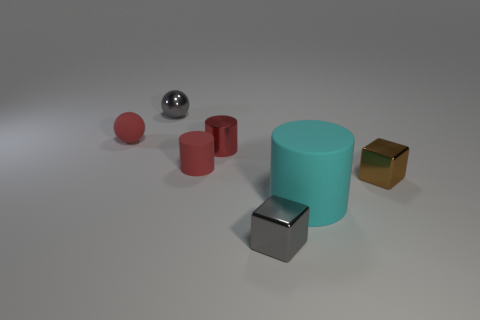Add 2 matte balls. How many objects exist? 9 Subtract all cylinders. How many objects are left? 4 Subtract all small cylinders. Subtract all cyan objects. How many objects are left? 4 Add 4 tiny red matte spheres. How many tiny red matte spheres are left? 5 Add 2 tiny yellow metal cubes. How many tiny yellow metal cubes exist? 2 Subtract 1 brown blocks. How many objects are left? 6 